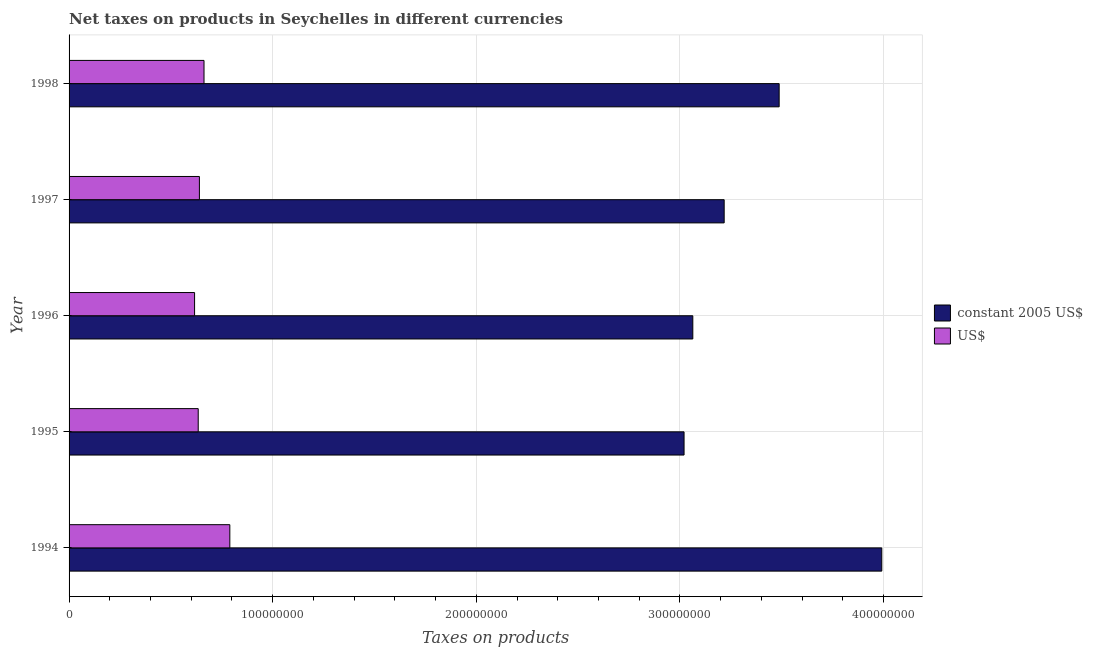How many different coloured bars are there?
Ensure brevity in your answer.  2. Are the number of bars on each tick of the Y-axis equal?
Your answer should be compact. Yes. What is the label of the 2nd group of bars from the top?
Your response must be concise. 1997. What is the net taxes in constant 2005 us$ in 1998?
Make the answer very short. 3.49e+08. Across all years, what is the maximum net taxes in us$?
Provide a succinct answer. 7.89e+07. Across all years, what is the minimum net taxes in constant 2005 us$?
Make the answer very short. 3.02e+08. In which year was the net taxes in us$ maximum?
Make the answer very short. 1994. In which year was the net taxes in us$ minimum?
Your answer should be very brief. 1996. What is the total net taxes in us$ in the graph?
Your answer should be compact. 3.34e+08. What is the difference between the net taxes in constant 2005 us$ in 1995 and that in 1998?
Your response must be concise. -4.67e+07. What is the difference between the net taxes in us$ in 1998 and the net taxes in constant 2005 us$ in 1994?
Offer a very short reply. -3.33e+08. What is the average net taxes in us$ per year?
Offer a very short reply. 6.69e+07. In the year 1996, what is the difference between the net taxes in constant 2005 us$ and net taxes in us$?
Give a very brief answer. 2.45e+08. In how many years, is the net taxes in constant 2005 us$ greater than 340000000 units?
Provide a short and direct response. 2. What is the ratio of the net taxes in constant 2005 us$ in 1996 to that in 1998?
Give a very brief answer. 0.88. Is the net taxes in us$ in 1994 less than that in 1995?
Provide a short and direct response. No. What is the difference between the highest and the second highest net taxes in constant 2005 us$?
Ensure brevity in your answer.  5.04e+07. What is the difference between the highest and the lowest net taxes in constant 2005 us$?
Offer a very short reply. 9.71e+07. In how many years, is the net taxes in constant 2005 us$ greater than the average net taxes in constant 2005 us$ taken over all years?
Your answer should be compact. 2. Is the sum of the net taxes in constant 2005 us$ in 1995 and 1997 greater than the maximum net taxes in us$ across all years?
Make the answer very short. Yes. What does the 2nd bar from the top in 1995 represents?
Your answer should be very brief. Constant 2005 us$. What does the 1st bar from the bottom in 1994 represents?
Provide a succinct answer. Constant 2005 us$. How many bars are there?
Your answer should be compact. 10. Are the values on the major ticks of X-axis written in scientific E-notation?
Your answer should be very brief. No. How are the legend labels stacked?
Your answer should be very brief. Vertical. What is the title of the graph?
Ensure brevity in your answer.  Net taxes on products in Seychelles in different currencies. What is the label or title of the X-axis?
Keep it short and to the point. Taxes on products. What is the Taxes on products in constant 2005 US$ in 1994?
Keep it short and to the point. 3.99e+08. What is the Taxes on products of US$ in 1994?
Offer a very short reply. 7.89e+07. What is the Taxes on products in constant 2005 US$ in 1995?
Provide a succinct answer. 3.02e+08. What is the Taxes on products of US$ in 1995?
Give a very brief answer. 6.34e+07. What is the Taxes on products in constant 2005 US$ in 1996?
Your response must be concise. 3.06e+08. What is the Taxes on products in US$ in 1996?
Provide a short and direct response. 6.16e+07. What is the Taxes on products of constant 2005 US$ in 1997?
Keep it short and to the point. 3.22e+08. What is the Taxes on products of US$ in 1997?
Give a very brief answer. 6.40e+07. What is the Taxes on products of constant 2005 US$ in 1998?
Provide a short and direct response. 3.49e+08. What is the Taxes on products in US$ in 1998?
Provide a short and direct response. 6.63e+07. Across all years, what is the maximum Taxes on products in constant 2005 US$?
Provide a short and direct response. 3.99e+08. Across all years, what is the maximum Taxes on products in US$?
Offer a very short reply. 7.89e+07. Across all years, what is the minimum Taxes on products of constant 2005 US$?
Offer a terse response. 3.02e+08. Across all years, what is the minimum Taxes on products of US$?
Offer a very short reply. 6.16e+07. What is the total Taxes on products in constant 2005 US$ in the graph?
Provide a succinct answer. 1.68e+09. What is the total Taxes on products in US$ in the graph?
Provide a short and direct response. 3.34e+08. What is the difference between the Taxes on products in constant 2005 US$ in 1994 and that in 1995?
Offer a terse response. 9.71e+07. What is the difference between the Taxes on products of US$ in 1994 and that in 1995?
Keep it short and to the point. 1.55e+07. What is the difference between the Taxes on products in constant 2005 US$ in 1994 and that in 1996?
Keep it short and to the point. 9.28e+07. What is the difference between the Taxes on products of US$ in 1994 and that in 1996?
Keep it short and to the point. 1.73e+07. What is the difference between the Taxes on products of constant 2005 US$ in 1994 and that in 1997?
Provide a short and direct response. 7.74e+07. What is the difference between the Taxes on products of US$ in 1994 and that in 1997?
Provide a short and direct response. 1.49e+07. What is the difference between the Taxes on products of constant 2005 US$ in 1994 and that in 1998?
Your response must be concise. 5.04e+07. What is the difference between the Taxes on products in US$ in 1994 and that in 1998?
Your answer should be compact. 1.27e+07. What is the difference between the Taxes on products in constant 2005 US$ in 1995 and that in 1996?
Your response must be concise. -4.30e+06. What is the difference between the Taxes on products of US$ in 1995 and that in 1996?
Provide a short and direct response. 1.79e+06. What is the difference between the Taxes on products of constant 2005 US$ in 1995 and that in 1997?
Your answer should be very brief. -1.97e+07. What is the difference between the Taxes on products in US$ in 1995 and that in 1997?
Provide a succinct answer. -5.83e+05. What is the difference between the Taxes on products of constant 2005 US$ in 1995 and that in 1998?
Provide a short and direct response. -4.67e+07. What is the difference between the Taxes on products in US$ in 1995 and that in 1998?
Your answer should be very brief. -2.85e+06. What is the difference between the Taxes on products of constant 2005 US$ in 1996 and that in 1997?
Give a very brief answer. -1.54e+07. What is the difference between the Taxes on products in US$ in 1996 and that in 1997?
Make the answer very short. -2.37e+06. What is the difference between the Taxes on products in constant 2005 US$ in 1996 and that in 1998?
Keep it short and to the point. -4.24e+07. What is the difference between the Taxes on products of US$ in 1996 and that in 1998?
Make the answer very short. -4.64e+06. What is the difference between the Taxes on products in constant 2005 US$ in 1997 and that in 1998?
Provide a short and direct response. -2.70e+07. What is the difference between the Taxes on products in US$ in 1997 and that in 1998?
Keep it short and to the point. -2.26e+06. What is the difference between the Taxes on products in constant 2005 US$ in 1994 and the Taxes on products in US$ in 1995?
Provide a short and direct response. 3.36e+08. What is the difference between the Taxes on products in constant 2005 US$ in 1994 and the Taxes on products in US$ in 1996?
Offer a terse response. 3.37e+08. What is the difference between the Taxes on products of constant 2005 US$ in 1994 and the Taxes on products of US$ in 1997?
Your response must be concise. 3.35e+08. What is the difference between the Taxes on products in constant 2005 US$ in 1994 and the Taxes on products in US$ in 1998?
Provide a short and direct response. 3.33e+08. What is the difference between the Taxes on products in constant 2005 US$ in 1995 and the Taxes on products in US$ in 1996?
Keep it short and to the point. 2.40e+08. What is the difference between the Taxes on products in constant 2005 US$ in 1995 and the Taxes on products in US$ in 1997?
Keep it short and to the point. 2.38e+08. What is the difference between the Taxes on products of constant 2005 US$ in 1995 and the Taxes on products of US$ in 1998?
Offer a terse response. 2.36e+08. What is the difference between the Taxes on products of constant 2005 US$ in 1996 and the Taxes on products of US$ in 1997?
Your answer should be compact. 2.42e+08. What is the difference between the Taxes on products of constant 2005 US$ in 1996 and the Taxes on products of US$ in 1998?
Your answer should be compact. 2.40e+08. What is the difference between the Taxes on products in constant 2005 US$ in 1997 and the Taxes on products in US$ in 1998?
Give a very brief answer. 2.55e+08. What is the average Taxes on products in constant 2005 US$ per year?
Keep it short and to the point. 3.36e+08. What is the average Taxes on products of US$ per year?
Your response must be concise. 6.69e+07. In the year 1994, what is the difference between the Taxes on products of constant 2005 US$ and Taxes on products of US$?
Your answer should be very brief. 3.20e+08. In the year 1995, what is the difference between the Taxes on products in constant 2005 US$ and Taxes on products in US$?
Your response must be concise. 2.39e+08. In the year 1996, what is the difference between the Taxes on products of constant 2005 US$ and Taxes on products of US$?
Provide a short and direct response. 2.45e+08. In the year 1997, what is the difference between the Taxes on products in constant 2005 US$ and Taxes on products in US$?
Offer a terse response. 2.58e+08. In the year 1998, what is the difference between the Taxes on products of constant 2005 US$ and Taxes on products of US$?
Provide a short and direct response. 2.82e+08. What is the ratio of the Taxes on products in constant 2005 US$ in 1994 to that in 1995?
Ensure brevity in your answer.  1.32. What is the ratio of the Taxes on products of US$ in 1994 to that in 1995?
Offer a very short reply. 1.24. What is the ratio of the Taxes on products in constant 2005 US$ in 1994 to that in 1996?
Offer a very short reply. 1.3. What is the ratio of the Taxes on products in US$ in 1994 to that in 1996?
Your response must be concise. 1.28. What is the ratio of the Taxes on products of constant 2005 US$ in 1994 to that in 1997?
Offer a very short reply. 1.24. What is the ratio of the Taxes on products of US$ in 1994 to that in 1997?
Make the answer very short. 1.23. What is the ratio of the Taxes on products in constant 2005 US$ in 1994 to that in 1998?
Your answer should be compact. 1.14. What is the ratio of the Taxes on products in US$ in 1994 to that in 1998?
Provide a short and direct response. 1.19. What is the ratio of the Taxes on products in constant 2005 US$ in 1995 to that in 1996?
Ensure brevity in your answer.  0.99. What is the ratio of the Taxes on products in constant 2005 US$ in 1995 to that in 1997?
Make the answer very short. 0.94. What is the ratio of the Taxes on products of US$ in 1995 to that in 1997?
Keep it short and to the point. 0.99. What is the ratio of the Taxes on products in constant 2005 US$ in 1995 to that in 1998?
Offer a terse response. 0.87. What is the ratio of the Taxes on products in constant 2005 US$ in 1996 to that in 1997?
Offer a terse response. 0.95. What is the ratio of the Taxes on products of US$ in 1996 to that in 1997?
Your answer should be compact. 0.96. What is the ratio of the Taxes on products in constant 2005 US$ in 1996 to that in 1998?
Provide a succinct answer. 0.88. What is the ratio of the Taxes on products of US$ in 1996 to that in 1998?
Provide a succinct answer. 0.93. What is the ratio of the Taxes on products in constant 2005 US$ in 1997 to that in 1998?
Your answer should be compact. 0.92. What is the ratio of the Taxes on products in US$ in 1997 to that in 1998?
Your response must be concise. 0.97. What is the difference between the highest and the second highest Taxes on products in constant 2005 US$?
Your answer should be very brief. 5.04e+07. What is the difference between the highest and the second highest Taxes on products of US$?
Give a very brief answer. 1.27e+07. What is the difference between the highest and the lowest Taxes on products of constant 2005 US$?
Offer a very short reply. 9.71e+07. What is the difference between the highest and the lowest Taxes on products in US$?
Offer a very short reply. 1.73e+07. 